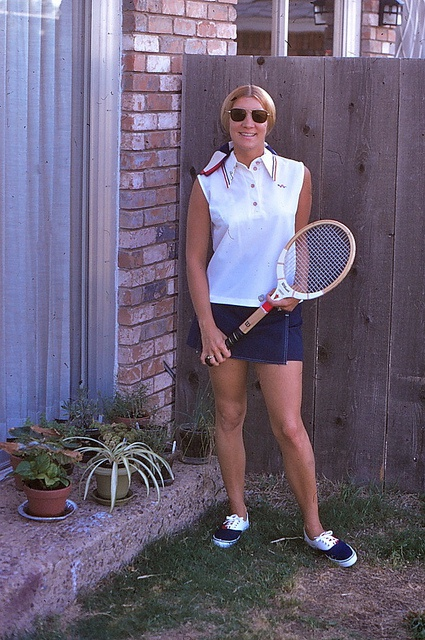Describe the objects in this image and their specific colors. I can see people in lavender, brown, and black tones, tennis racket in lavender, black, and darkgray tones, potted plant in lavender, gray, black, and darkgray tones, potted plant in lavender, black, maroon, gray, and brown tones, and potted plant in lavender, gray, black, and darkblue tones in this image. 